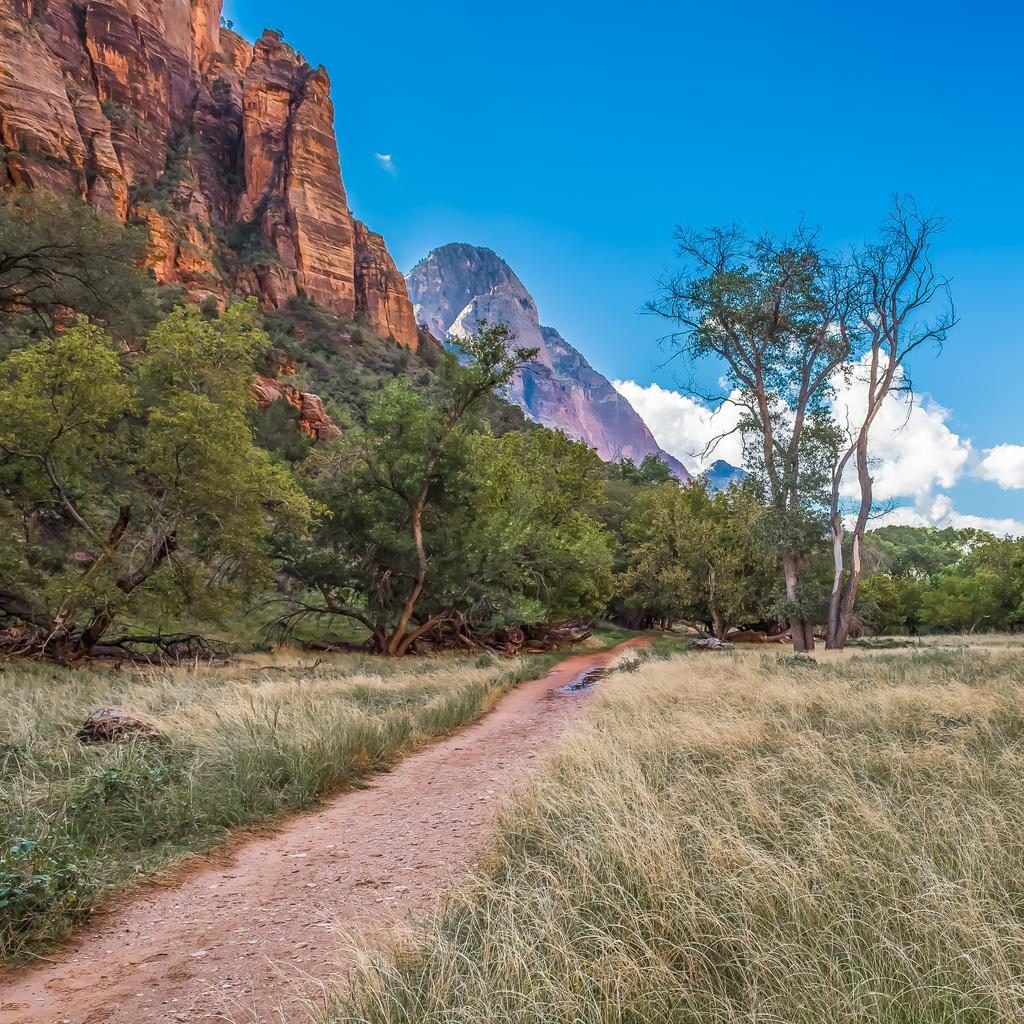What type of vegetation can be seen in the image? There is grass in the image. What other natural elements are present in the image? There are trees and mountains in the image. What is visible in the background of the image? The sky is visible in the image. What can be seen in the sky? There are clouds in the sky. What is the number of faucets visible in the image? There are no faucets present in the image. 